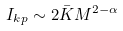<formula> <loc_0><loc_0><loc_500><loc_500>I _ { k p } \sim 2 \bar { K } M ^ { 2 - \alpha }</formula> 